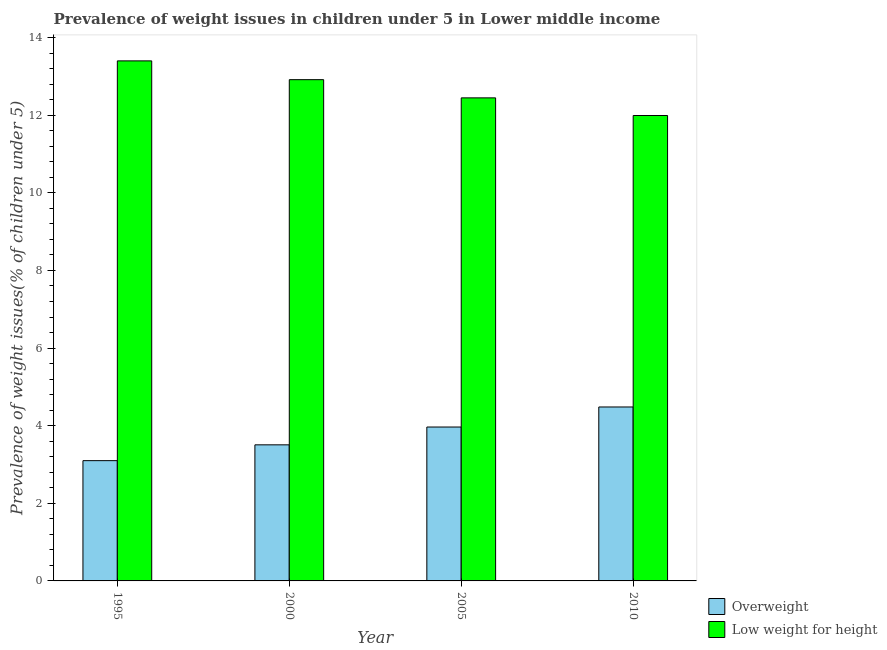How many different coloured bars are there?
Offer a very short reply. 2. How many groups of bars are there?
Provide a short and direct response. 4. Are the number of bars per tick equal to the number of legend labels?
Provide a succinct answer. Yes. Are the number of bars on each tick of the X-axis equal?
Your response must be concise. Yes. How many bars are there on the 3rd tick from the left?
Your response must be concise. 2. What is the percentage of overweight children in 1995?
Your answer should be very brief. 3.1. Across all years, what is the maximum percentage of overweight children?
Offer a terse response. 4.48. Across all years, what is the minimum percentage of overweight children?
Your answer should be very brief. 3.1. What is the total percentage of overweight children in the graph?
Offer a terse response. 15.05. What is the difference between the percentage of underweight children in 2000 and that in 2005?
Your response must be concise. 0.47. What is the difference between the percentage of underweight children in 1995 and the percentage of overweight children in 2010?
Keep it short and to the point. 1.41. What is the average percentage of underweight children per year?
Make the answer very short. 12.69. What is the ratio of the percentage of overweight children in 2000 to that in 2010?
Make the answer very short. 0.78. What is the difference between the highest and the second highest percentage of underweight children?
Your answer should be very brief. 0.48. What is the difference between the highest and the lowest percentage of underweight children?
Offer a terse response. 1.41. In how many years, is the percentage of overweight children greater than the average percentage of overweight children taken over all years?
Your answer should be compact. 2. Is the sum of the percentage of overweight children in 2000 and 2010 greater than the maximum percentage of underweight children across all years?
Give a very brief answer. Yes. What does the 1st bar from the left in 1995 represents?
Provide a succinct answer. Overweight. What does the 1st bar from the right in 2005 represents?
Keep it short and to the point. Low weight for height. How many bars are there?
Offer a terse response. 8. Are all the bars in the graph horizontal?
Your response must be concise. No. How many years are there in the graph?
Offer a terse response. 4. How many legend labels are there?
Provide a short and direct response. 2. How are the legend labels stacked?
Your answer should be very brief. Vertical. What is the title of the graph?
Your answer should be very brief. Prevalence of weight issues in children under 5 in Lower middle income. What is the label or title of the Y-axis?
Offer a very short reply. Prevalence of weight issues(% of children under 5). What is the Prevalence of weight issues(% of children under 5) of Overweight in 1995?
Your response must be concise. 3.1. What is the Prevalence of weight issues(% of children under 5) in Low weight for height in 1995?
Give a very brief answer. 13.4. What is the Prevalence of weight issues(% of children under 5) of Overweight in 2000?
Ensure brevity in your answer.  3.51. What is the Prevalence of weight issues(% of children under 5) of Low weight for height in 2000?
Your answer should be very brief. 12.92. What is the Prevalence of weight issues(% of children under 5) of Overweight in 2005?
Your response must be concise. 3.97. What is the Prevalence of weight issues(% of children under 5) of Low weight for height in 2005?
Your response must be concise. 12.45. What is the Prevalence of weight issues(% of children under 5) in Overweight in 2010?
Provide a short and direct response. 4.48. What is the Prevalence of weight issues(% of children under 5) of Low weight for height in 2010?
Make the answer very short. 11.99. Across all years, what is the maximum Prevalence of weight issues(% of children under 5) of Overweight?
Give a very brief answer. 4.48. Across all years, what is the maximum Prevalence of weight issues(% of children under 5) of Low weight for height?
Your answer should be very brief. 13.4. Across all years, what is the minimum Prevalence of weight issues(% of children under 5) of Overweight?
Provide a short and direct response. 3.1. Across all years, what is the minimum Prevalence of weight issues(% of children under 5) of Low weight for height?
Ensure brevity in your answer.  11.99. What is the total Prevalence of weight issues(% of children under 5) in Overweight in the graph?
Give a very brief answer. 15.05. What is the total Prevalence of weight issues(% of children under 5) of Low weight for height in the graph?
Provide a succinct answer. 50.75. What is the difference between the Prevalence of weight issues(% of children under 5) in Overweight in 1995 and that in 2000?
Offer a very short reply. -0.41. What is the difference between the Prevalence of weight issues(% of children under 5) in Low weight for height in 1995 and that in 2000?
Give a very brief answer. 0.48. What is the difference between the Prevalence of weight issues(% of children under 5) in Overweight in 1995 and that in 2005?
Provide a short and direct response. -0.87. What is the difference between the Prevalence of weight issues(% of children under 5) in Low weight for height in 1995 and that in 2005?
Give a very brief answer. 0.95. What is the difference between the Prevalence of weight issues(% of children under 5) of Overweight in 1995 and that in 2010?
Your response must be concise. -1.38. What is the difference between the Prevalence of weight issues(% of children under 5) of Low weight for height in 1995 and that in 2010?
Your answer should be compact. 1.41. What is the difference between the Prevalence of weight issues(% of children under 5) of Overweight in 2000 and that in 2005?
Your response must be concise. -0.46. What is the difference between the Prevalence of weight issues(% of children under 5) in Low weight for height in 2000 and that in 2005?
Provide a succinct answer. 0.47. What is the difference between the Prevalence of weight issues(% of children under 5) of Overweight in 2000 and that in 2010?
Your answer should be very brief. -0.98. What is the difference between the Prevalence of weight issues(% of children under 5) of Low weight for height in 2000 and that in 2010?
Provide a succinct answer. 0.92. What is the difference between the Prevalence of weight issues(% of children under 5) of Overweight in 2005 and that in 2010?
Your response must be concise. -0.52. What is the difference between the Prevalence of weight issues(% of children under 5) of Low weight for height in 2005 and that in 2010?
Offer a very short reply. 0.45. What is the difference between the Prevalence of weight issues(% of children under 5) of Overweight in 1995 and the Prevalence of weight issues(% of children under 5) of Low weight for height in 2000?
Your answer should be compact. -9.82. What is the difference between the Prevalence of weight issues(% of children under 5) in Overweight in 1995 and the Prevalence of weight issues(% of children under 5) in Low weight for height in 2005?
Provide a short and direct response. -9.35. What is the difference between the Prevalence of weight issues(% of children under 5) of Overweight in 1995 and the Prevalence of weight issues(% of children under 5) of Low weight for height in 2010?
Provide a succinct answer. -8.89. What is the difference between the Prevalence of weight issues(% of children under 5) of Overweight in 2000 and the Prevalence of weight issues(% of children under 5) of Low weight for height in 2005?
Your answer should be compact. -8.94. What is the difference between the Prevalence of weight issues(% of children under 5) of Overweight in 2000 and the Prevalence of weight issues(% of children under 5) of Low weight for height in 2010?
Provide a short and direct response. -8.49. What is the difference between the Prevalence of weight issues(% of children under 5) in Overweight in 2005 and the Prevalence of weight issues(% of children under 5) in Low weight for height in 2010?
Offer a terse response. -8.03. What is the average Prevalence of weight issues(% of children under 5) in Overweight per year?
Your answer should be compact. 3.76. What is the average Prevalence of weight issues(% of children under 5) of Low weight for height per year?
Your answer should be very brief. 12.69. In the year 1995, what is the difference between the Prevalence of weight issues(% of children under 5) in Overweight and Prevalence of weight issues(% of children under 5) in Low weight for height?
Keep it short and to the point. -10.3. In the year 2000, what is the difference between the Prevalence of weight issues(% of children under 5) of Overweight and Prevalence of weight issues(% of children under 5) of Low weight for height?
Your answer should be very brief. -9.41. In the year 2005, what is the difference between the Prevalence of weight issues(% of children under 5) of Overweight and Prevalence of weight issues(% of children under 5) of Low weight for height?
Your answer should be compact. -8.48. In the year 2010, what is the difference between the Prevalence of weight issues(% of children under 5) of Overweight and Prevalence of weight issues(% of children under 5) of Low weight for height?
Your answer should be very brief. -7.51. What is the ratio of the Prevalence of weight issues(% of children under 5) of Overweight in 1995 to that in 2000?
Give a very brief answer. 0.88. What is the ratio of the Prevalence of weight issues(% of children under 5) in Low weight for height in 1995 to that in 2000?
Offer a terse response. 1.04. What is the ratio of the Prevalence of weight issues(% of children under 5) in Overweight in 1995 to that in 2005?
Make the answer very short. 0.78. What is the ratio of the Prevalence of weight issues(% of children under 5) in Low weight for height in 1995 to that in 2005?
Make the answer very short. 1.08. What is the ratio of the Prevalence of weight issues(% of children under 5) in Overweight in 1995 to that in 2010?
Provide a succinct answer. 0.69. What is the ratio of the Prevalence of weight issues(% of children under 5) in Low weight for height in 1995 to that in 2010?
Provide a succinct answer. 1.12. What is the ratio of the Prevalence of weight issues(% of children under 5) of Overweight in 2000 to that in 2005?
Offer a very short reply. 0.88. What is the ratio of the Prevalence of weight issues(% of children under 5) of Low weight for height in 2000 to that in 2005?
Make the answer very short. 1.04. What is the ratio of the Prevalence of weight issues(% of children under 5) in Overweight in 2000 to that in 2010?
Offer a very short reply. 0.78. What is the ratio of the Prevalence of weight issues(% of children under 5) in Low weight for height in 2000 to that in 2010?
Give a very brief answer. 1.08. What is the ratio of the Prevalence of weight issues(% of children under 5) in Overweight in 2005 to that in 2010?
Provide a short and direct response. 0.88. What is the ratio of the Prevalence of weight issues(% of children under 5) of Low weight for height in 2005 to that in 2010?
Make the answer very short. 1.04. What is the difference between the highest and the second highest Prevalence of weight issues(% of children under 5) in Overweight?
Provide a short and direct response. 0.52. What is the difference between the highest and the second highest Prevalence of weight issues(% of children under 5) in Low weight for height?
Your response must be concise. 0.48. What is the difference between the highest and the lowest Prevalence of weight issues(% of children under 5) in Overweight?
Provide a succinct answer. 1.38. What is the difference between the highest and the lowest Prevalence of weight issues(% of children under 5) of Low weight for height?
Your answer should be compact. 1.41. 